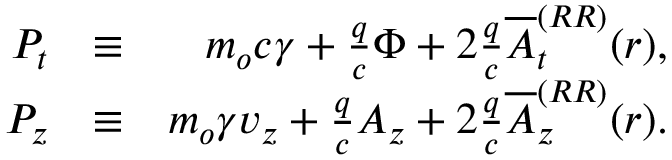<formula> <loc_0><loc_0><loc_500><loc_500>\begin{array} { r l r } { P _ { t } } & { \equiv } & { m _ { o } c \gamma + \frac { q } { c } \Phi + 2 \frac { q } { c } \overline { A } _ { t } ^ { ( R R ) } ( r ) , } \\ { P _ { z } } & { \equiv } & { m _ { o } \gamma v _ { z } + \frac { q } { c } A _ { z } + 2 \frac { q } { c } \overline { A } _ { z } ^ { ( R R ) } ( r ) . } \end{array}</formula> 